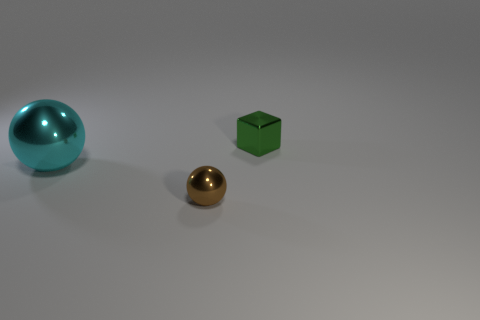Are there any other things that are the same size as the cyan metal sphere?
Provide a succinct answer. No. What color is the big metal sphere?
Keep it short and to the point. Cyan. How many metallic objects are small green cubes or cyan balls?
Your response must be concise. 2. There is a small metal thing that is the same shape as the large cyan metal object; what color is it?
Provide a short and direct response. Brown. Are there any small shiny things?
Your answer should be very brief. Yes. What number of objects are either green objects that are behind the brown object or large metal things to the left of the tiny brown ball?
Provide a succinct answer. 2. What is the shape of the metal object that is both behind the brown shiny thing and on the right side of the large cyan object?
Make the answer very short. Cube. The metallic cube that is the same size as the brown shiny ball is what color?
Your answer should be very brief. Green. There is a object that is in front of the large cyan metallic thing; is it the same size as the shiny object that is right of the brown ball?
Your answer should be compact. Yes. How many other objects are the same size as the green cube?
Make the answer very short. 1. 